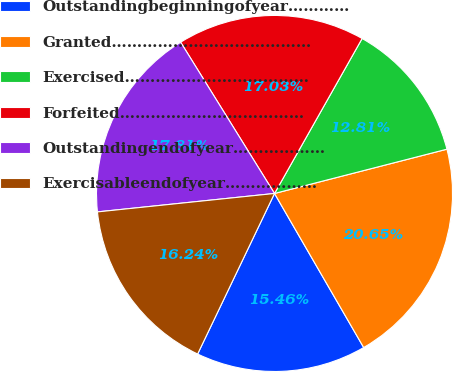Convert chart. <chart><loc_0><loc_0><loc_500><loc_500><pie_chart><fcel>Outstandingbeginningofyear…………<fcel>Granted…………………………………<fcel>Exercised………………………………<fcel>Forfeited………………………………<fcel>Outstandingendofyear………………<fcel>Exercisableendofyear………………<nl><fcel>15.46%<fcel>20.65%<fcel>12.81%<fcel>17.03%<fcel>17.81%<fcel>16.24%<nl></chart> 